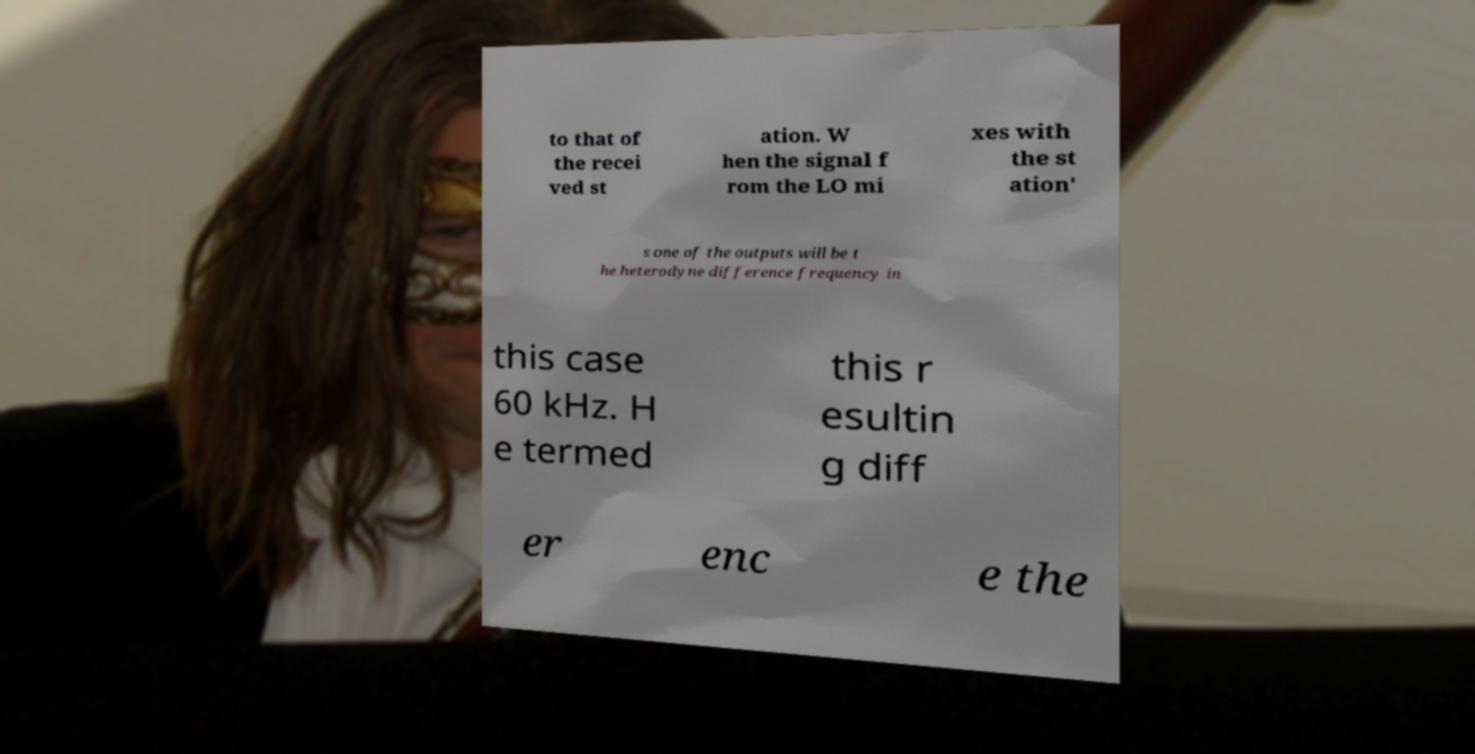I need the written content from this picture converted into text. Can you do that? to that of the recei ved st ation. W hen the signal f rom the LO mi xes with the st ation' s one of the outputs will be t he heterodyne difference frequency in this case 60 kHz. H e termed this r esultin g diff er enc e the 